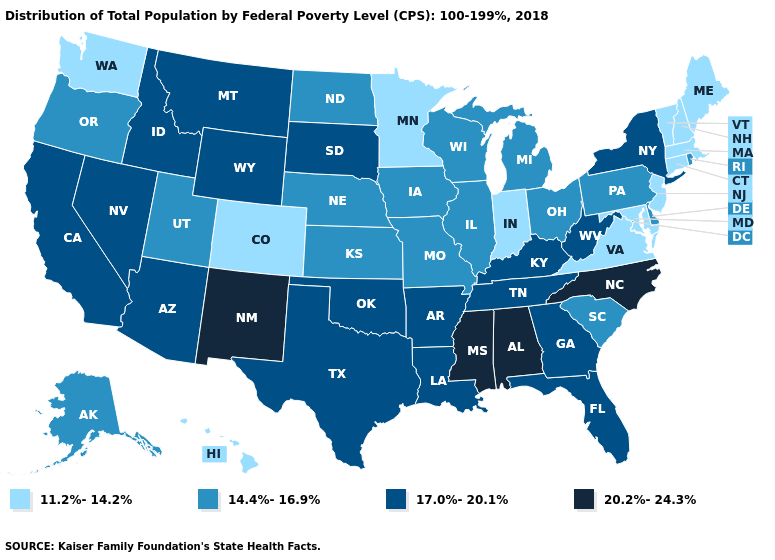What is the lowest value in states that border Missouri?
Concise answer only. 14.4%-16.9%. What is the lowest value in states that border Rhode Island?
Short answer required. 11.2%-14.2%. Does New Mexico have the highest value in the West?
Give a very brief answer. Yes. What is the value of Idaho?
Write a very short answer. 17.0%-20.1%. What is the value of Arkansas?
Give a very brief answer. 17.0%-20.1%. Does the first symbol in the legend represent the smallest category?
Be succinct. Yes. Name the states that have a value in the range 17.0%-20.1%?
Give a very brief answer. Arizona, Arkansas, California, Florida, Georgia, Idaho, Kentucky, Louisiana, Montana, Nevada, New York, Oklahoma, South Dakota, Tennessee, Texas, West Virginia, Wyoming. Does Florida have the highest value in the USA?
Write a very short answer. No. Name the states that have a value in the range 20.2%-24.3%?
Answer briefly. Alabama, Mississippi, New Mexico, North Carolina. Does New Hampshire have the same value as Virginia?
Concise answer only. Yes. How many symbols are there in the legend?
Write a very short answer. 4. Name the states that have a value in the range 14.4%-16.9%?
Be succinct. Alaska, Delaware, Illinois, Iowa, Kansas, Michigan, Missouri, Nebraska, North Dakota, Ohio, Oregon, Pennsylvania, Rhode Island, South Carolina, Utah, Wisconsin. Name the states that have a value in the range 17.0%-20.1%?
Give a very brief answer. Arizona, Arkansas, California, Florida, Georgia, Idaho, Kentucky, Louisiana, Montana, Nevada, New York, Oklahoma, South Dakota, Tennessee, Texas, West Virginia, Wyoming. Which states have the lowest value in the MidWest?
Short answer required. Indiana, Minnesota. Among the states that border Maine , which have the lowest value?
Concise answer only. New Hampshire. 